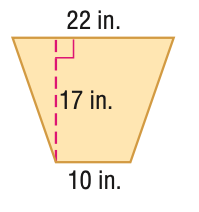Question: Find the area of the trapezoid.
Choices:
A. 68
B. 136
C. 272
D. 544
Answer with the letter. Answer: C 